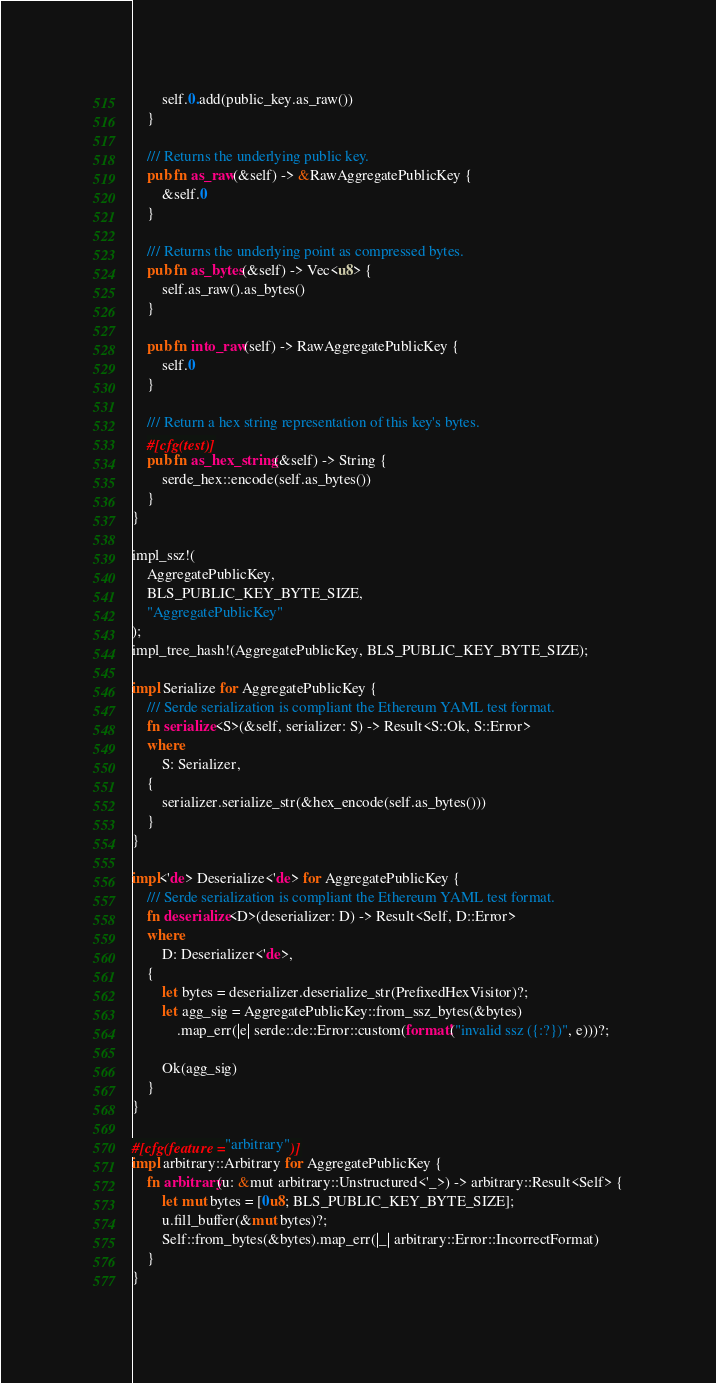Convert code to text. <code><loc_0><loc_0><loc_500><loc_500><_Rust_>        self.0.add(public_key.as_raw())
    }

    /// Returns the underlying public key.
    pub fn as_raw(&self) -> &RawAggregatePublicKey {
        &self.0
    }

    /// Returns the underlying point as compressed bytes.
    pub fn as_bytes(&self) -> Vec<u8> {
        self.as_raw().as_bytes()
    }

    pub fn into_raw(self) -> RawAggregatePublicKey {
        self.0
    }

    /// Return a hex string representation of this key's bytes.
    #[cfg(test)]
    pub fn as_hex_string(&self) -> String {
        serde_hex::encode(self.as_bytes())
    }
}

impl_ssz!(
    AggregatePublicKey,
    BLS_PUBLIC_KEY_BYTE_SIZE,
    "AggregatePublicKey"
);
impl_tree_hash!(AggregatePublicKey, BLS_PUBLIC_KEY_BYTE_SIZE);

impl Serialize for AggregatePublicKey {
    /// Serde serialization is compliant the Ethereum YAML test format.
    fn serialize<S>(&self, serializer: S) -> Result<S::Ok, S::Error>
    where
        S: Serializer,
    {
        serializer.serialize_str(&hex_encode(self.as_bytes()))
    }
}

impl<'de> Deserialize<'de> for AggregatePublicKey {
    /// Serde serialization is compliant the Ethereum YAML test format.
    fn deserialize<D>(deserializer: D) -> Result<Self, D::Error>
    where
        D: Deserializer<'de>,
    {
        let bytes = deserializer.deserialize_str(PrefixedHexVisitor)?;
        let agg_sig = AggregatePublicKey::from_ssz_bytes(&bytes)
            .map_err(|e| serde::de::Error::custom(format!("invalid ssz ({:?})", e)))?;

        Ok(agg_sig)
    }
}

#[cfg(feature = "arbitrary")]
impl arbitrary::Arbitrary for AggregatePublicKey {
    fn arbitrary(u: &mut arbitrary::Unstructured<'_>) -> arbitrary::Result<Self> {
        let mut bytes = [0u8; BLS_PUBLIC_KEY_BYTE_SIZE];
        u.fill_buffer(&mut bytes)?;
        Self::from_bytes(&bytes).map_err(|_| arbitrary::Error::IncorrectFormat)
    }
}
</code> 